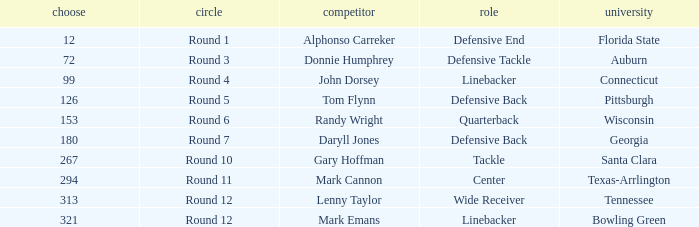In what Round was Pick #12 drafted? Round 1. 